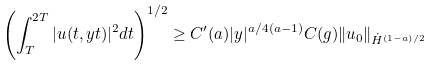<formula> <loc_0><loc_0><loc_500><loc_500>\left ( \int _ { T } ^ { 2 T } | u ( t , y t ) | ^ { 2 } d t \right ) ^ { 1 / 2 } \geq C ^ { \prime } ( a ) | y | ^ { a / 4 ( a - 1 ) } C ( g ) \| u _ { 0 } \| _ { \dot { H } ^ { ( 1 - a ) / 2 } }</formula> 